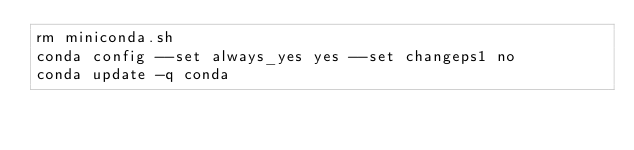<code> <loc_0><loc_0><loc_500><loc_500><_Bash_>rm miniconda.sh
conda config --set always_yes yes --set changeps1 no
conda update -q conda

</code> 